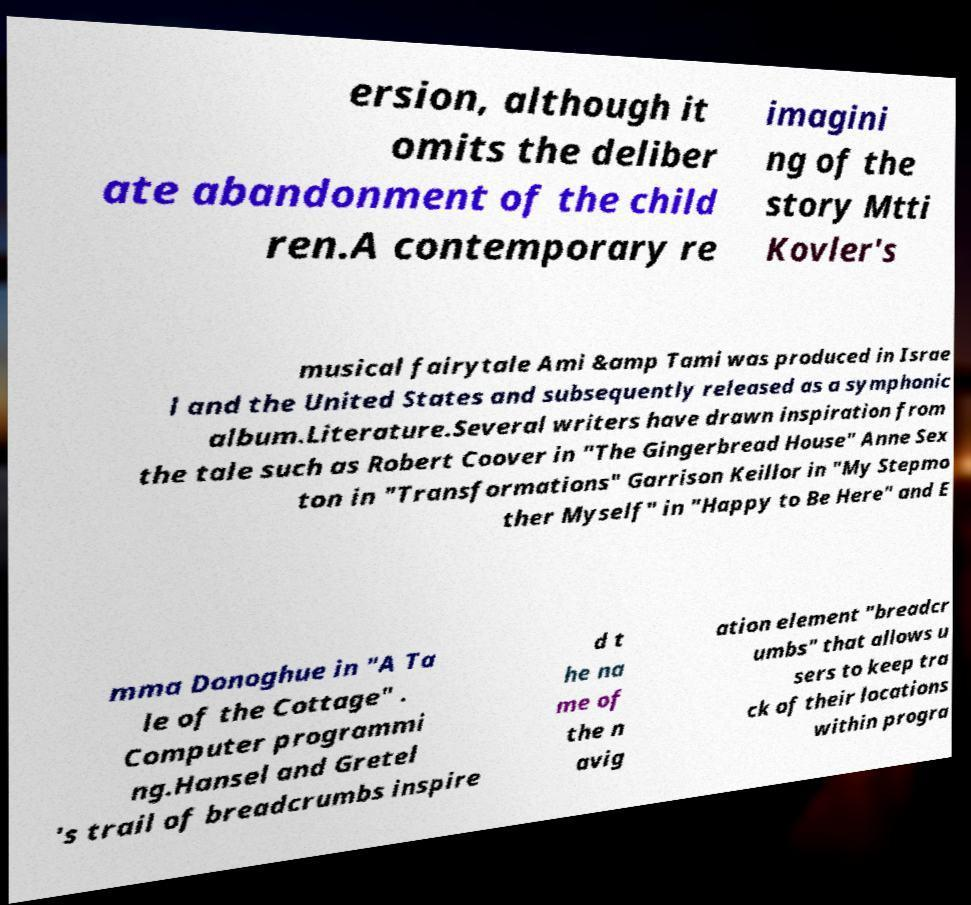Please identify and transcribe the text found in this image. ersion, although it omits the deliber ate abandonment of the child ren.A contemporary re imagini ng of the story Mtti Kovler's musical fairytale Ami &amp Tami was produced in Israe l and the United States and subsequently released as a symphonic album.Literature.Several writers have drawn inspiration from the tale such as Robert Coover in "The Gingerbread House" Anne Sex ton in "Transformations" Garrison Keillor in "My Stepmo ther Myself" in "Happy to Be Here" and E mma Donoghue in "A Ta le of the Cottage" . Computer programmi ng.Hansel and Gretel 's trail of breadcrumbs inspire d t he na me of the n avig ation element "breadcr umbs" that allows u sers to keep tra ck of their locations within progra 